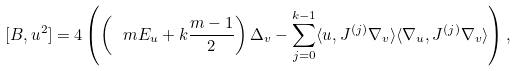<formula> <loc_0><loc_0><loc_500><loc_500>[ B , u ^ { 2 } ] = 4 \left ( \left ( \ m E _ { u } + k \frac { m - 1 } { 2 } \right ) \Delta _ { v } - \sum _ { j = 0 } ^ { k - 1 } \langle u , J ^ { ( j ) } \nabla _ { v } \rangle \langle \nabla _ { u } , J ^ { ( j ) } \nabla _ { v } \rangle \right ) ,</formula> 